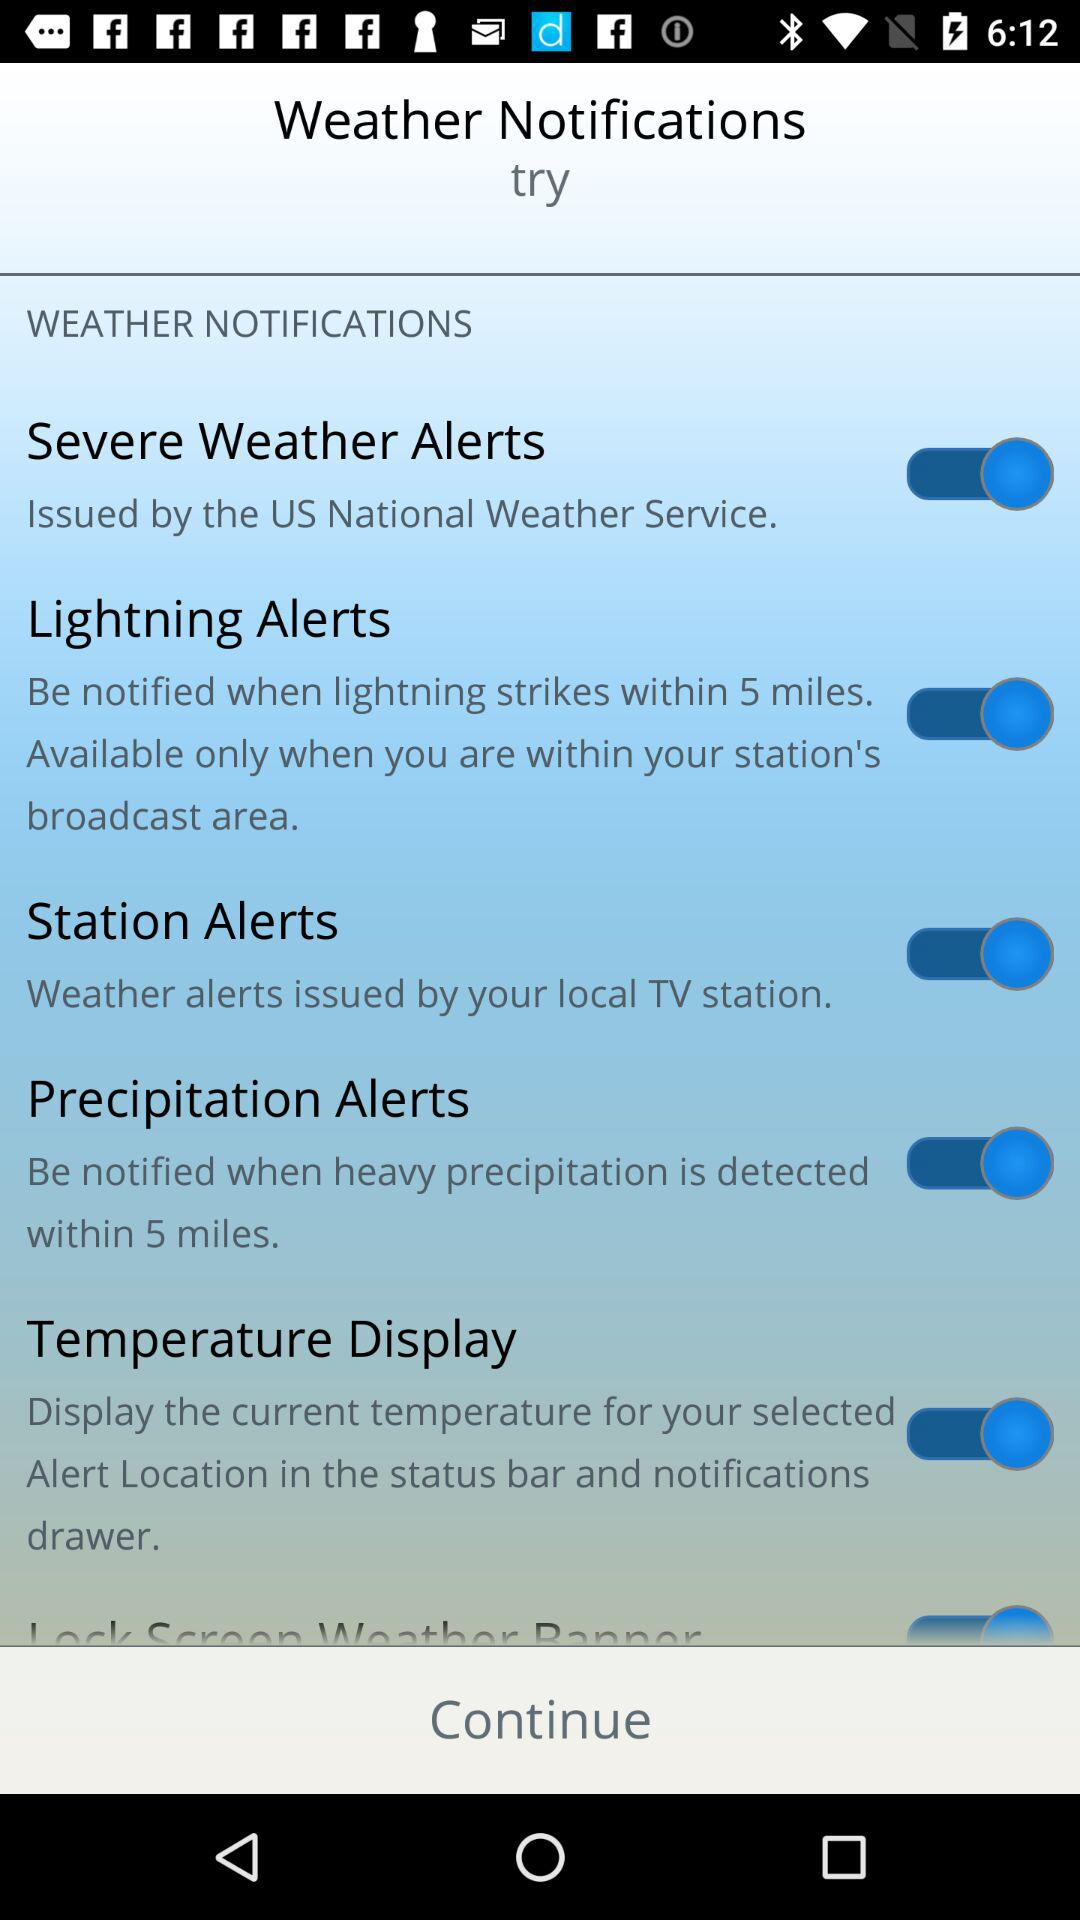Which company is the application powered by?
When the provided information is insufficient, respond with <no answer>. <no answer> 